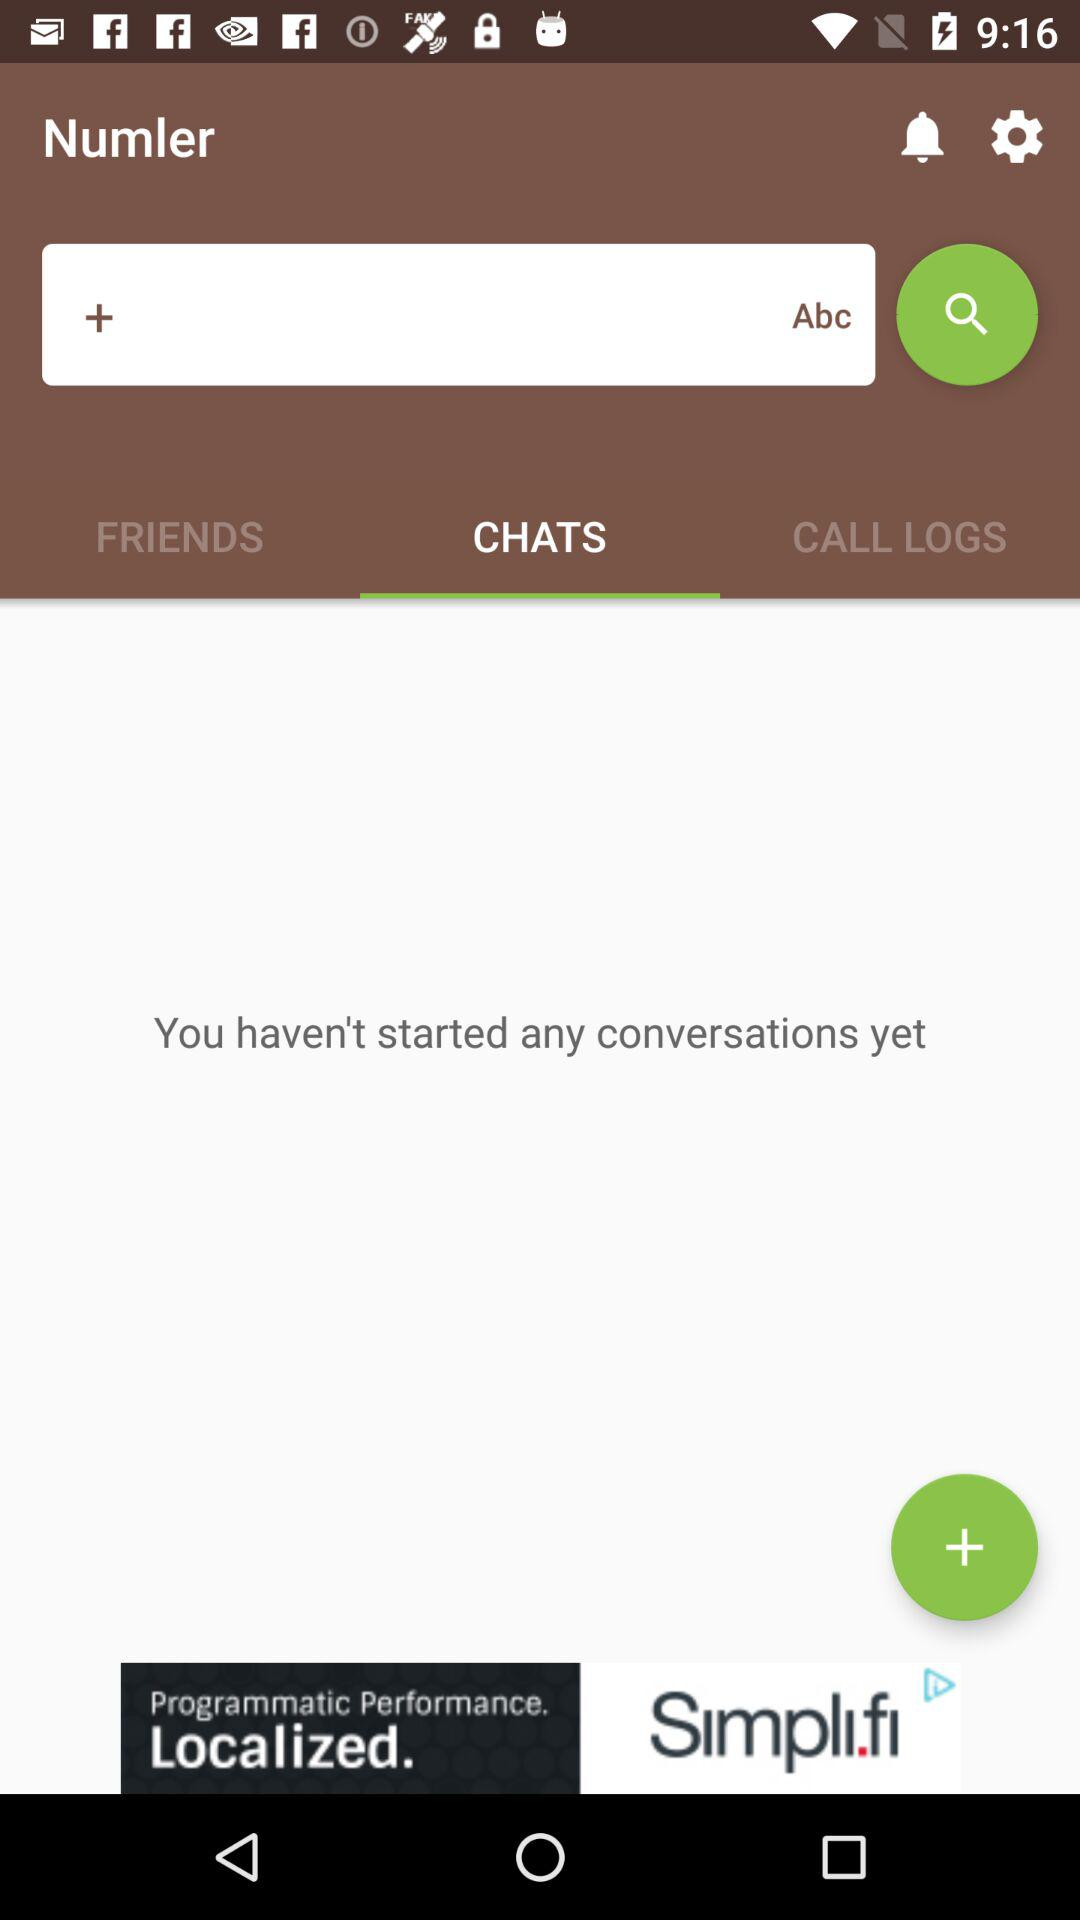How many items are in "CALL LOGS"?
When the provided information is insufficient, respond with <no answer>. <no answer> 